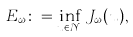<formula> <loc_0><loc_0><loc_500><loc_500>E _ { \omega } \colon = \inf _ { u \in \mathcal { N } _ { \omega } } J _ { \omega } ( u ) ,</formula> 